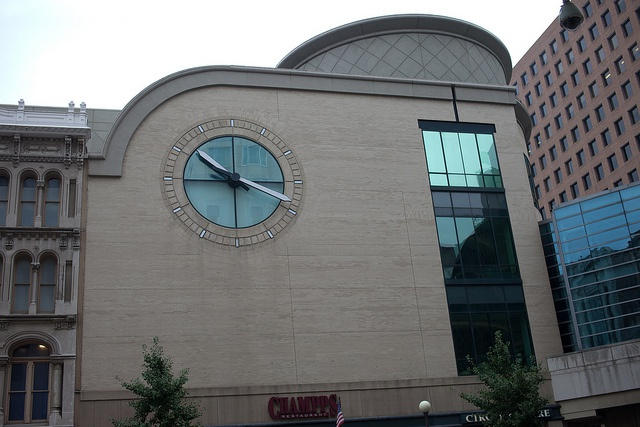Describe the objects in this image and their specific colors. I can see a clock in white, gray, and teal tones in this image. 